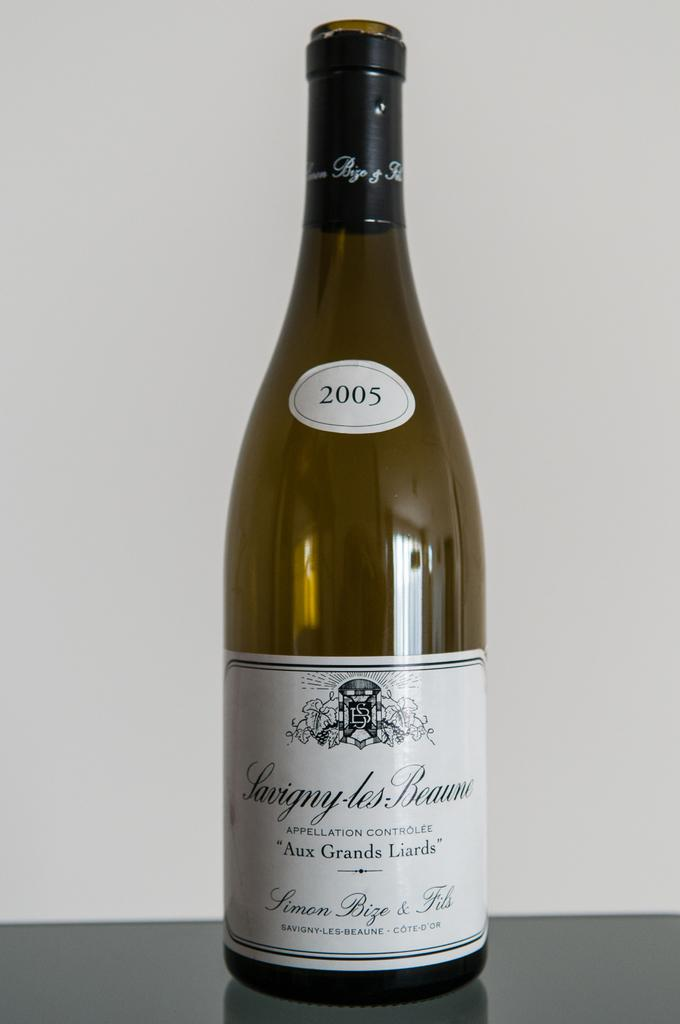<image>
Relay a brief, clear account of the picture shown. A bottle of Savigny-les-Beaune from 2005 with a white label. 